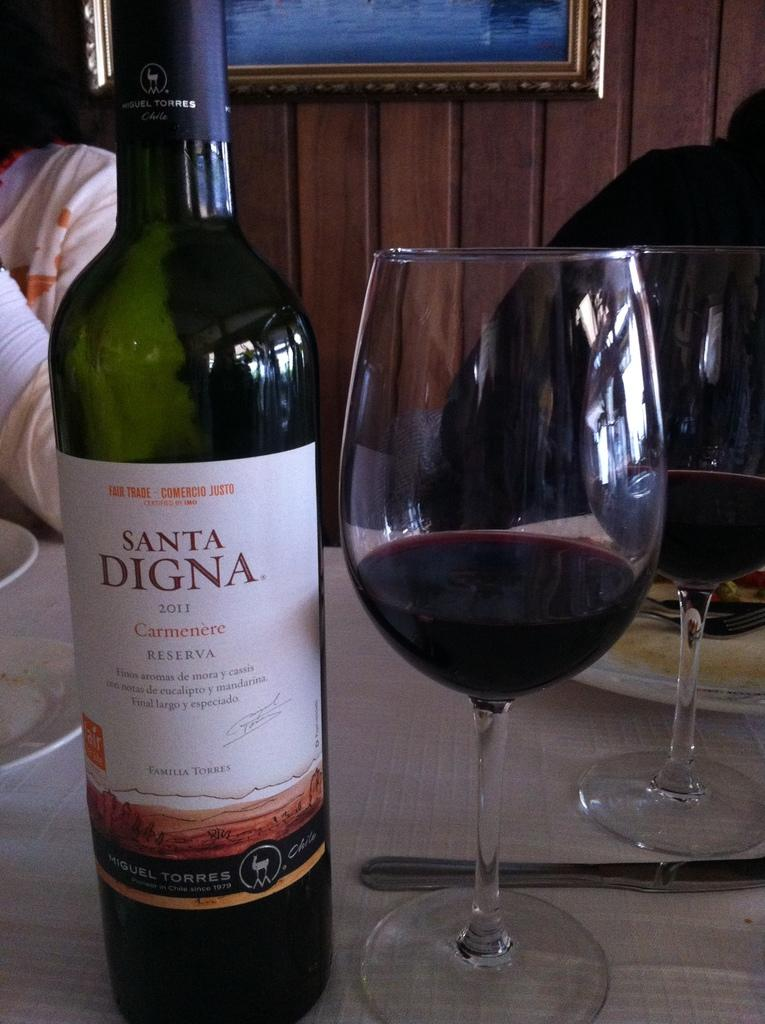<image>
Create a compact narrative representing the image presented. A bottle of Santa Digna 2011 Carmenere is next to a wine glass. 